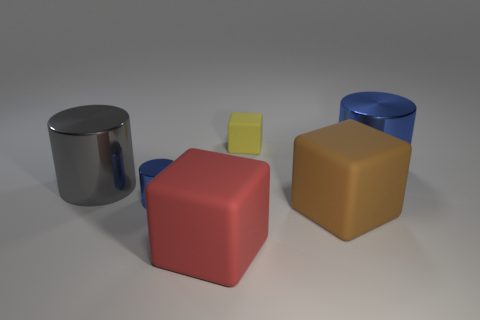Are there any other things that have the same size as the gray thing?
Your answer should be compact. Yes. The big metal object that is in front of the big metal object that is to the right of the yellow rubber block is what shape?
Your answer should be compact. Cylinder. Are there fewer red matte blocks than small brown shiny cylinders?
Ensure brevity in your answer.  No. There is a thing that is both right of the small yellow cube and behind the big brown rubber block; how big is it?
Offer a very short reply. Large. Is the red matte object the same size as the yellow cube?
Offer a terse response. No. Do the large matte block right of the large red object and the tiny cube have the same color?
Make the answer very short. No. What number of small rubber things are in front of the big gray cylinder?
Offer a very short reply. 0. Is the number of large blue metal cylinders greater than the number of big metallic things?
Provide a short and direct response. No. What shape is the large thing that is both right of the red matte cube and behind the large brown matte thing?
Provide a short and direct response. Cylinder. Is there a brown rubber thing?
Give a very brief answer. Yes. 